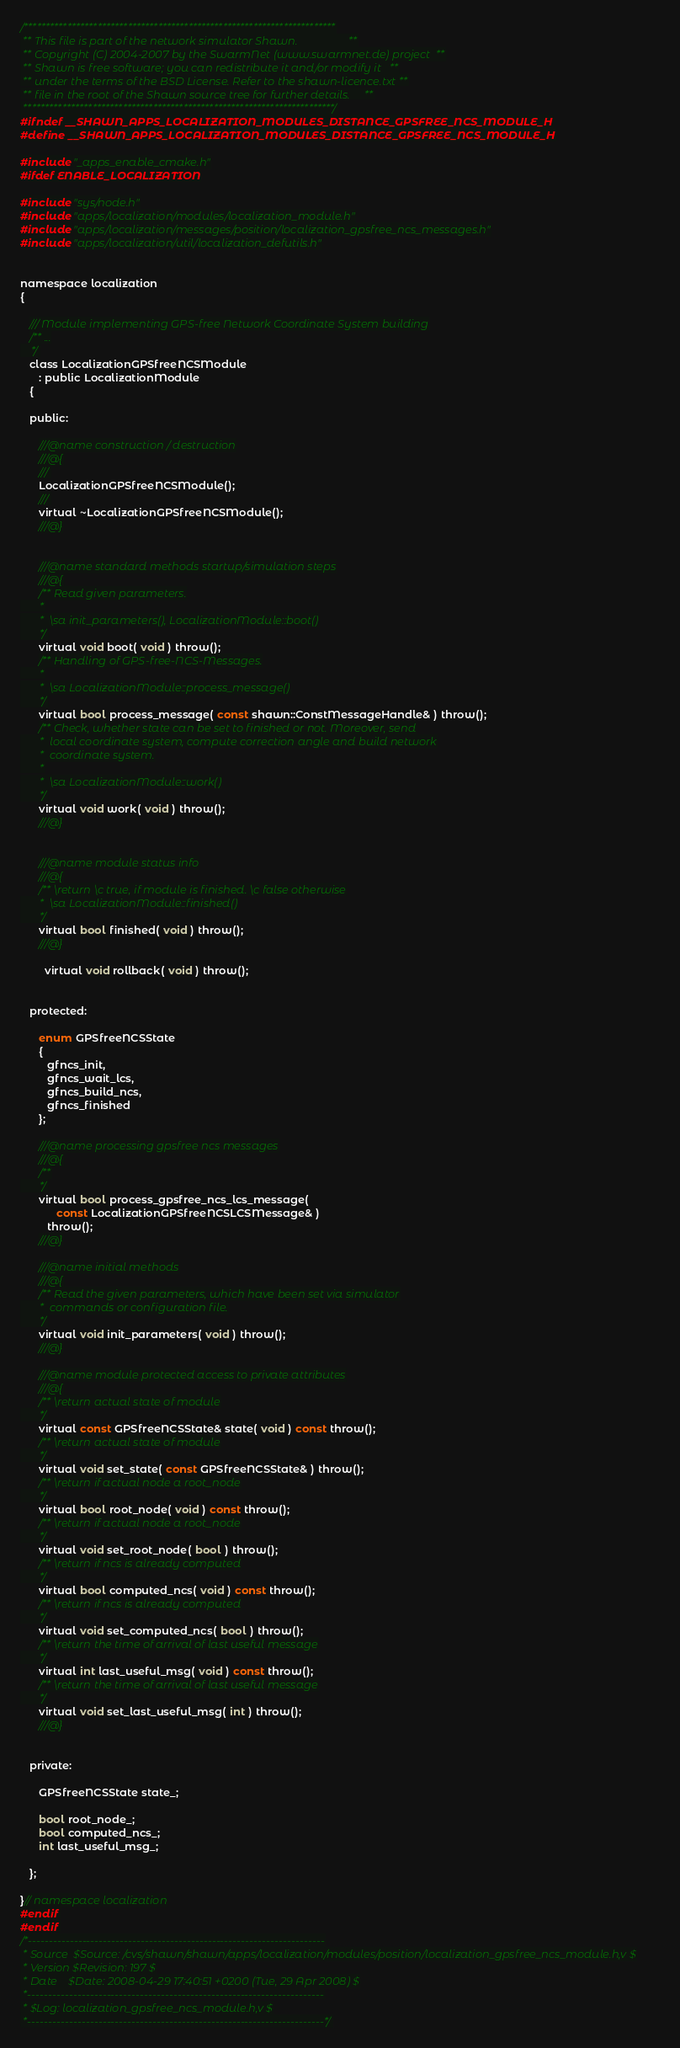Convert code to text. <code><loc_0><loc_0><loc_500><loc_500><_C_>/************************************************************************
 ** This file is part of the network simulator Shawn.                  **
 ** Copyright (C) 2004-2007 by the SwarmNet (www.swarmnet.de) project  **
 ** Shawn is free software; you can redistribute it and/or modify it   **
 ** under the terms of the BSD License. Refer to the shawn-licence.txt **
 ** file in the root of the Shawn source tree for further details.     **
 ************************************************************************/
#ifndef __SHAWN_APPS_LOCALIZATION_MODULES_DISTANCE_GPSFREE_NCS_MODULE_H
#define __SHAWN_APPS_LOCALIZATION_MODULES_DISTANCE_GPSFREE_NCS_MODULE_H

#include "_apps_enable_cmake.h"
#ifdef ENABLE_LOCALIZATION

#include "sys/node.h"
#include "apps/localization/modules/localization_module.h"
#include "apps/localization/messages/position/localization_gpsfree_ncs_messages.h"
#include "apps/localization/util/localization_defutils.h"


namespace localization
{

   /// Module implementing GPS-free Network Coordinate System building
   /** ...
    */
   class LocalizationGPSfreeNCSModule
      : public LocalizationModule
   {

   public:

      ///@name construction / destruction
      ///@{
      ///
      LocalizationGPSfreeNCSModule();
      ///
      virtual ~LocalizationGPSfreeNCSModule();
      ///@}


      ///@name standard methods startup/simulation steps
      ///@{
      /** Read given parameters.
       *
       *  \sa init_parameters(), LocalizationModule::boot()
       */
      virtual void boot( void ) throw();
      /** Handling of GPS-free-NCS-Messages.
       *
       *  \sa LocalizationModule::process_message()
       */
      virtual bool process_message( const shawn::ConstMessageHandle& ) throw();
      /** Check, whether state can be set to finished or not. Moreover, send
       *  local coordinate system, compute correction angle and build network
       *  coordinate system.
       *
       *  \sa LocalizationModule::work()
       */
      virtual void work( void ) throw();
      ///@}


      ///@name module status info
      ///@{
      /** \return \c true, if module is finished. \c false otherwise
       *  \sa LocalizationModule::finished()
       */
      virtual bool finished( void ) throw();
      ///@}

		virtual void rollback( void ) throw();


   protected:

      enum GPSfreeNCSState
      {
         gfncs_init,
         gfncs_wait_lcs,
         gfncs_build_ncs,
         gfncs_finished
      };

      ///@name processing gpsfree ncs messages
      ///@{
      /**
       */
      virtual bool process_gpsfree_ncs_lcs_message(
            const LocalizationGPSfreeNCSLCSMessage& )
         throw();
      ///@}

      ///@name initial methods
      ///@{
      /** Read the given parameters, which have been set via simulator
       *  commands or configuration file.
       */
      virtual void init_parameters( void ) throw();
      ///@}

      ///@name module protected access to private attributes
      ///@{
      /** \return actual state of module
       */
      virtual const GPSfreeNCSState& state( void ) const throw();
      /** \return actual state of module
       */
      virtual void set_state( const GPSfreeNCSState& ) throw();
      /** \return if actual node a root_node
       */
      virtual bool root_node( void ) const throw();
      /** \return if actual node a root_node
       */
      virtual void set_root_node( bool ) throw();
      /** \return if ncs is already computed
       */
      virtual bool computed_ncs( void ) const throw();
      /** \return if ncs is already computed
       */
      virtual void set_computed_ncs( bool ) throw();
      /** \return the time of arrival of last useful message
       */
      virtual int last_useful_msg( void ) const throw();
      /** \return the time of arrival of last useful message
       */
      virtual void set_last_useful_msg( int ) throw();
      ///@}


   private:

      GPSfreeNCSState state_;

      bool root_node_;
      bool computed_ncs_;
      int last_useful_msg_;

   };

}// namespace localization
#endif
#endif
/*-----------------------------------------------------------------------
 * Source  $Source: /cvs/shawn/shawn/apps/localization/modules/position/localization_gpsfree_ncs_module.h,v $
 * Version $Revision: 197 $
 * Date    $Date: 2008-04-29 17:40:51 +0200 (Tue, 29 Apr 2008) $
 *-----------------------------------------------------------------------
 * $Log: localization_gpsfree_ncs_module.h,v $
 *-----------------------------------------------------------------------*/
</code> 